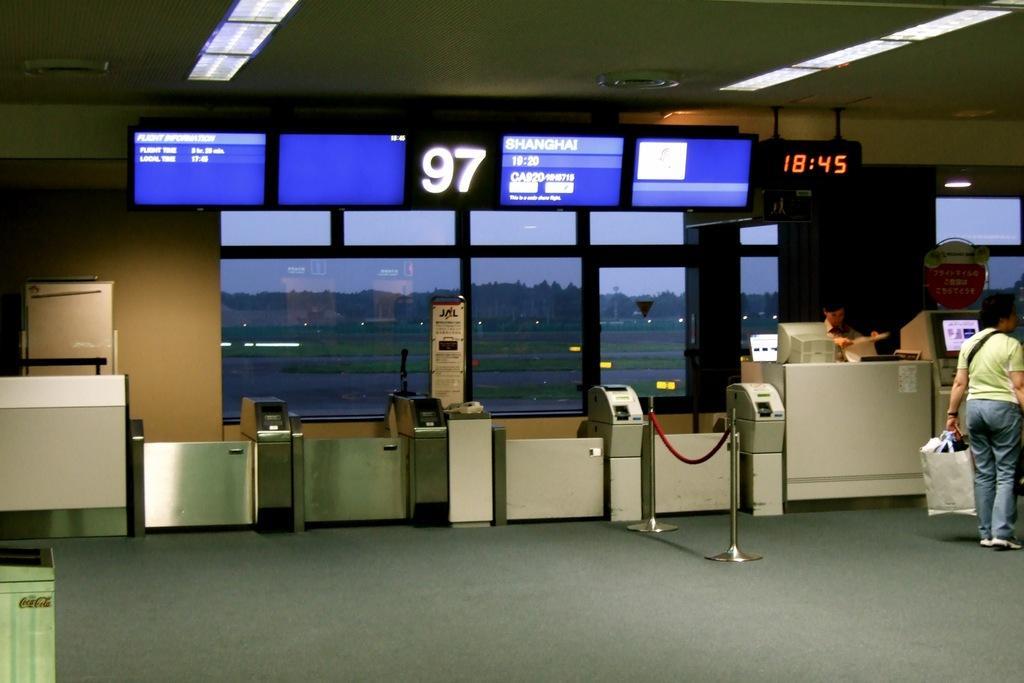Describe this image in one or two sentences. This image is clicked inside the hall in which there are four countries in the middle. At the top there is a digital board. At the top there is ceiling with the lights. On the right side there is a person who is holding the bag. Beside the person there is a desk on which there is a computer. At the top there is a time watch. There are poles in front of the counters. On the left side there are boxes and some objects. 